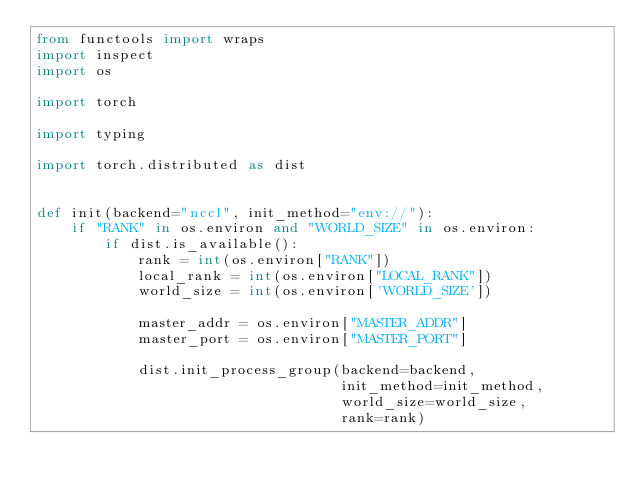<code> <loc_0><loc_0><loc_500><loc_500><_Python_>from functools import wraps
import inspect
import os

import torch

import typing

import torch.distributed as dist


def init(backend="nccl", init_method="env://"):
    if "RANK" in os.environ and "WORLD_SIZE" in os.environ:
        if dist.is_available():
            rank = int(os.environ["RANK"])
            local_rank = int(os.environ["LOCAL_RANK"])
            world_size = int(os.environ['WORLD_SIZE'])

            master_addr = os.environ["MASTER_ADDR"]
            master_port = os.environ["MASTER_PORT"]

            dist.init_process_group(backend=backend,
                                    init_method=init_method,
                                    world_size=world_size,
                                    rank=rank)</code> 